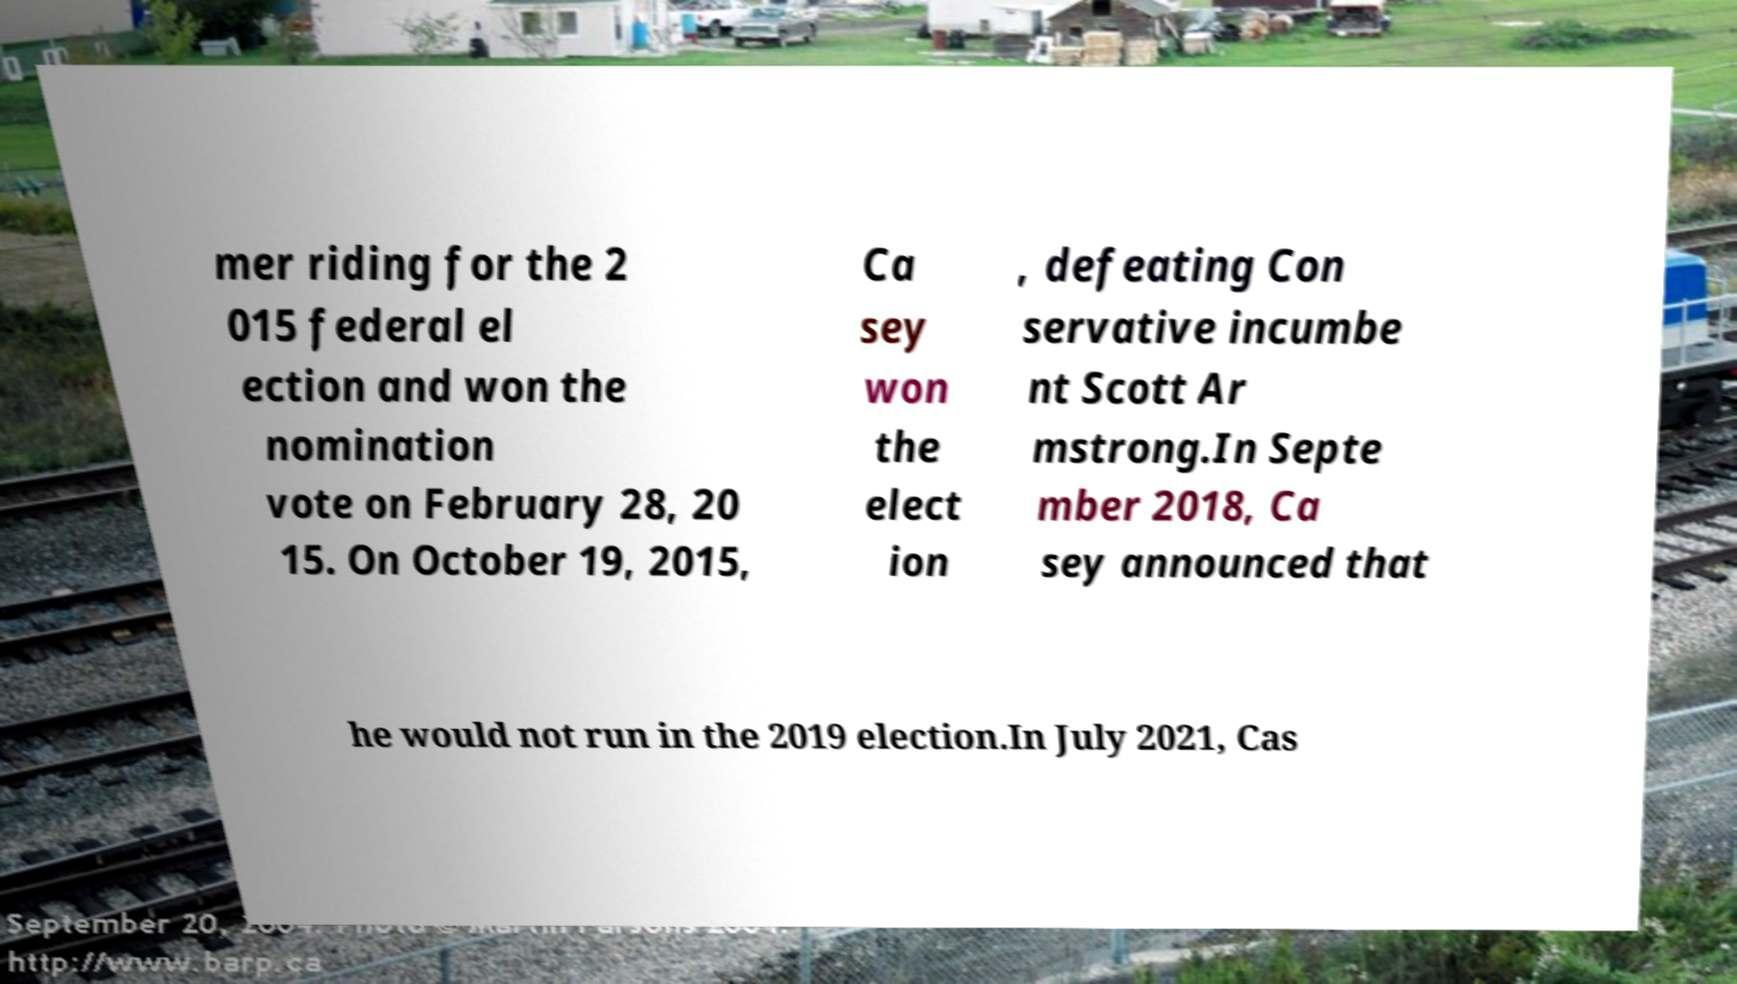Can you read and provide the text displayed in the image?This photo seems to have some interesting text. Can you extract and type it out for me? mer riding for the 2 015 federal el ection and won the nomination vote on February 28, 20 15. On October 19, 2015, Ca sey won the elect ion , defeating Con servative incumbe nt Scott Ar mstrong.In Septe mber 2018, Ca sey announced that he would not run in the 2019 election.In July 2021, Cas 